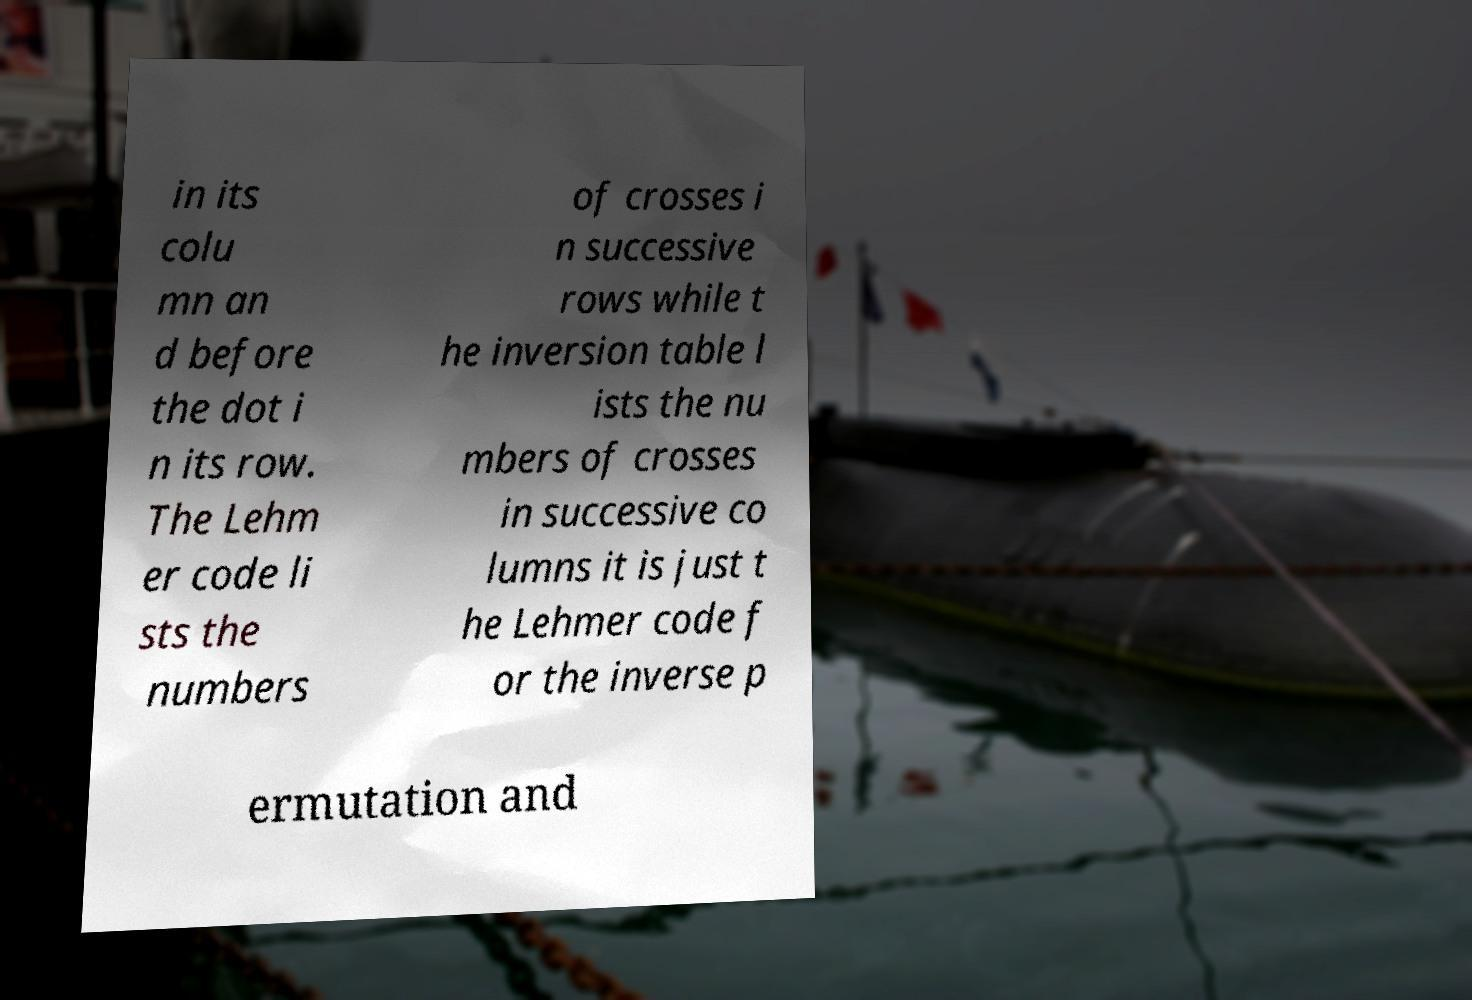For documentation purposes, I need the text within this image transcribed. Could you provide that? in its colu mn an d before the dot i n its row. The Lehm er code li sts the numbers of crosses i n successive rows while t he inversion table l ists the nu mbers of crosses in successive co lumns it is just t he Lehmer code f or the inverse p ermutation and 